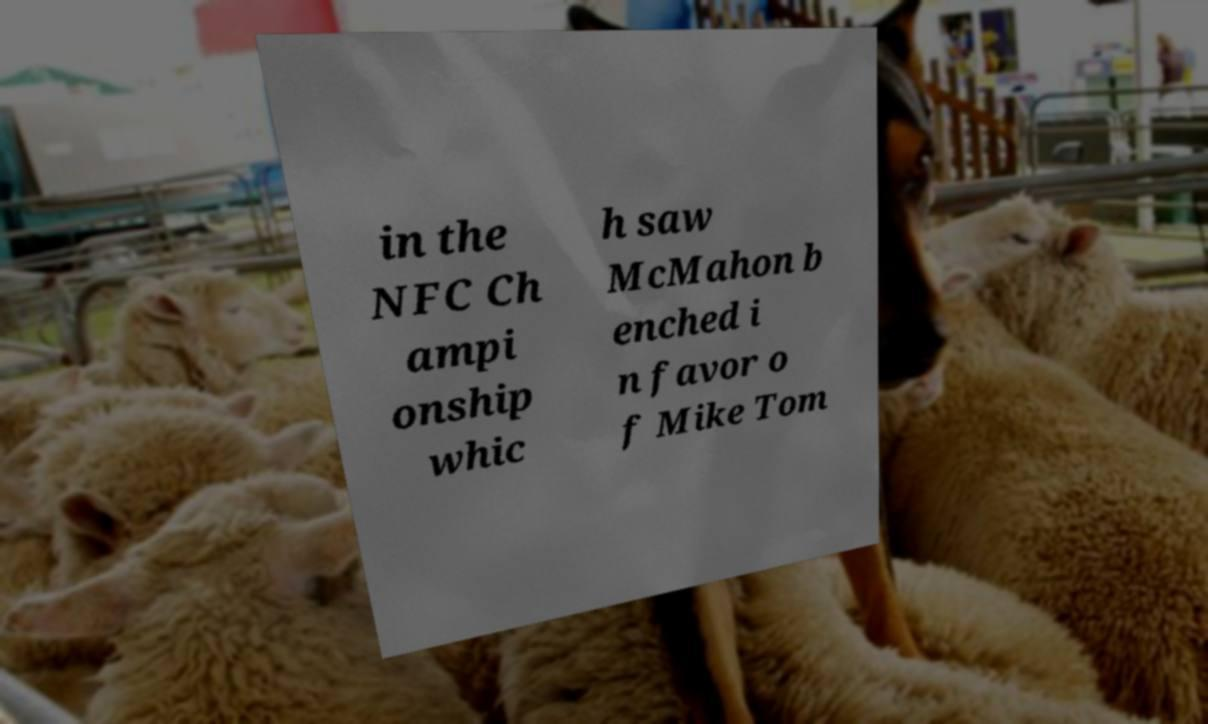There's text embedded in this image that I need extracted. Can you transcribe it verbatim? in the NFC Ch ampi onship whic h saw McMahon b enched i n favor o f Mike Tom 